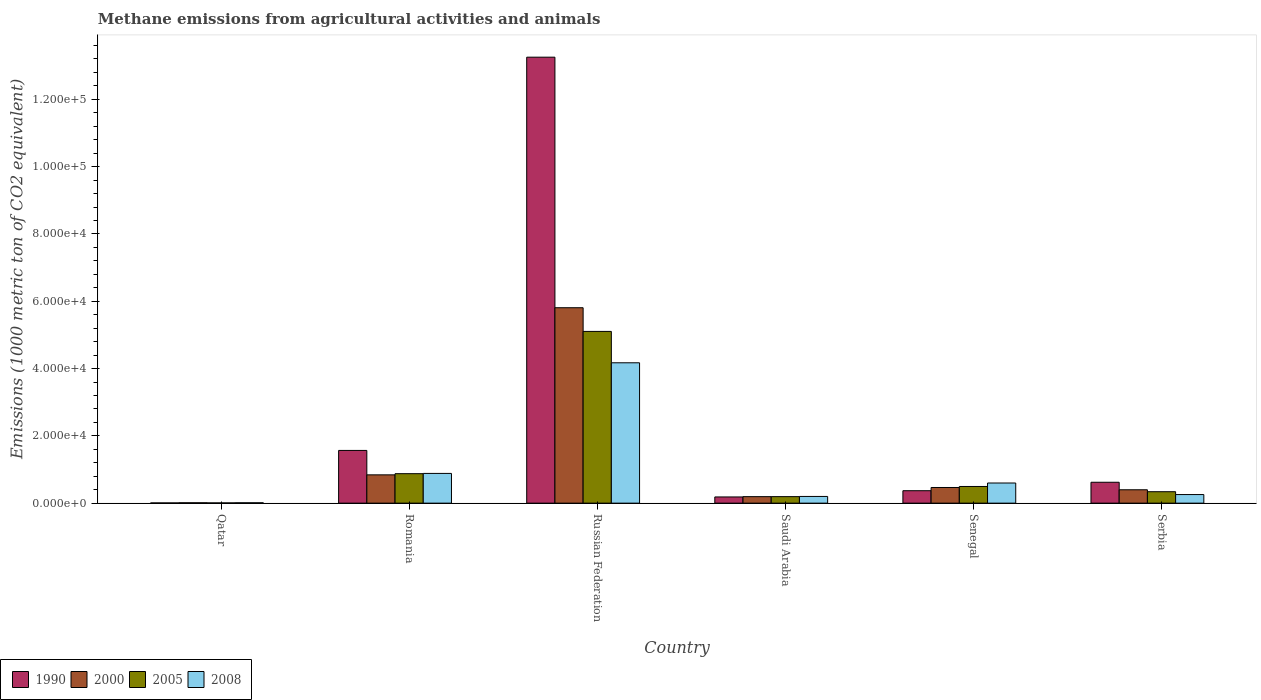How many different coloured bars are there?
Ensure brevity in your answer.  4. Are the number of bars on each tick of the X-axis equal?
Offer a terse response. Yes. How many bars are there on the 4th tick from the left?
Keep it short and to the point. 4. What is the label of the 6th group of bars from the left?
Ensure brevity in your answer.  Serbia. In how many cases, is the number of bars for a given country not equal to the number of legend labels?
Give a very brief answer. 0. What is the amount of methane emitted in 2000 in Qatar?
Your answer should be compact. 111.5. Across all countries, what is the maximum amount of methane emitted in 2000?
Provide a short and direct response. 5.81e+04. Across all countries, what is the minimum amount of methane emitted in 1990?
Your answer should be compact. 63.8. In which country was the amount of methane emitted in 1990 maximum?
Your answer should be very brief. Russian Federation. In which country was the amount of methane emitted in 2008 minimum?
Your response must be concise. Qatar. What is the total amount of methane emitted in 2000 in the graph?
Offer a very short reply. 7.72e+04. What is the difference between the amount of methane emitted in 2005 in Qatar and that in Saudi Arabia?
Offer a very short reply. -1866.2. What is the difference between the amount of methane emitted in 2005 in Senegal and the amount of methane emitted in 2000 in Serbia?
Provide a short and direct response. 979.8. What is the average amount of methane emitted in 1990 per country?
Keep it short and to the point. 2.67e+04. What is the difference between the amount of methane emitted of/in 2005 and amount of methane emitted of/in 2008 in Qatar?
Your answer should be very brief. -42.6. In how many countries, is the amount of methane emitted in 2008 greater than 64000 1000 metric ton?
Provide a succinct answer. 0. What is the ratio of the amount of methane emitted in 1990 in Qatar to that in Senegal?
Your answer should be very brief. 0.02. What is the difference between the highest and the second highest amount of methane emitted in 1990?
Your answer should be compact. 9455.9. What is the difference between the highest and the lowest amount of methane emitted in 2000?
Ensure brevity in your answer.  5.80e+04. In how many countries, is the amount of methane emitted in 2005 greater than the average amount of methane emitted in 2005 taken over all countries?
Make the answer very short. 1. What does the 1st bar from the left in Saudi Arabia represents?
Your response must be concise. 1990. Is it the case that in every country, the sum of the amount of methane emitted in 2000 and amount of methane emitted in 2005 is greater than the amount of methane emitted in 1990?
Your response must be concise. No. How many bars are there?
Provide a short and direct response. 24. Are all the bars in the graph horizontal?
Your answer should be very brief. No. How many countries are there in the graph?
Provide a short and direct response. 6. What is the difference between two consecutive major ticks on the Y-axis?
Provide a short and direct response. 2.00e+04. Are the values on the major ticks of Y-axis written in scientific E-notation?
Provide a succinct answer. Yes. Does the graph contain any zero values?
Ensure brevity in your answer.  No. Does the graph contain grids?
Make the answer very short. No. What is the title of the graph?
Your response must be concise. Methane emissions from agricultural activities and animals. Does "1968" appear as one of the legend labels in the graph?
Your answer should be compact. No. What is the label or title of the X-axis?
Your answer should be compact. Country. What is the label or title of the Y-axis?
Ensure brevity in your answer.  Emissions (1000 metric ton of CO2 equivalent). What is the Emissions (1000 metric ton of CO2 equivalent) of 1990 in Qatar?
Give a very brief answer. 63.8. What is the Emissions (1000 metric ton of CO2 equivalent) in 2000 in Qatar?
Offer a terse response. 111.5. What is the Emissions (1000 metric ton of CO2 equivalent) in 2005 in Qatar?
Your answer should be very brief. 67.4. What is the Emissions (1000 metric ton of CO2 equivalent) of 2008 in Qatar?
Your answer should be very brief. 110. What is the Emissions (1000 metric ton of CO2 equivalent) in 1990 in Romania?
Provide a succinct answer. 1.57e+04. What is the Emissions (1000 metric ton of CO2 equivalent) in 2000 in Romania?
Your answer should be very brief. 8409.3. What is the Emissions (1000 metric ton of CO2 equivalent) of 2005 in Romania?
Your response must be concise. 8756.8. What is the Emissions (1000 metric ton of CO2 equivalent) in 2008 in Romania?
Offer a very short reply. 8834.7. What is the Emissions (1000 metric ton of CO2 equivalent) of 1990 in Russian Federation?
Your response must be concise. 1.33e+05. What is the Emissions (1000 metric ton of CO2 equivalent) in 2000 in Russian Federation?
Ensure brevity in your answer.  5.81e+04. What is the Emissions (1000 metric ton of CO2 equivalent) of 2005 in Russian Federation?
Offer a terse response. 5.10e+04. What is the Emissions (1000 metric ton of CO2 equivalent) in 2008 in Russian Federation?
Offer a very short reply. 4.17e+04. What is the Emissions (1000 metric ton of CO2 equivalent) of 1990 in Saudi Arabia?
Your answer should be very brief. 1840.2. What is the Emissions (1000 metric ton of CO2 equivalent) of 2000 in Saudi Arabia?
Give a very brief answer. 1928.5. What is the Emissions (1000 metric ton of CO2 equivalent) of 2005 in Saudi Arabia?
Make the answer very short. 1933.6. What is the Emissions (1000 metric ton of CO2 equivalent) in 2008 in Saudi Arabia?
Make the answer very short. 1991.7. What is the Emissions (1000 metric ton of CO2 equivalent) of 1990 in Senegal?
Make the answer very short. 3695.6. What is the Emissions (1000 metric ton of CO2 equivalent) in 2000 in Senegal?
Your answer should be very brief. 4650.7. What is the Emissions (1000 metric ton of CO2 equivalent) of 2005 in Senegal?
Make the answer very short. 4955.1. What is the Emissions (1000 metric ton of CO2 equivalent) in 2008 in Senegal?
Your answer should be very brief. 5984.9. What is the Emissions (1000 metric ton of CO2 equivalent) in 1990 in Serbia?
Give a very brief answer. 6208.8. What is the Emissions (1000 metric ton of CO2 equivalent) of 2000 in Serbia?
Your answer should be very brief. 3975.3. What is the Emissions (1000 metric ton of CO2 equivalent) of 2005 in Serbia?
Your answer should be compact. 3399.6. What is the Emissions (1000 metric ton of CO2 equivalent) of 2008 in Serbia?
Offer a very short reply. 2550.7. Across all countries, what is the maximum Emissions (1000 metric ton of CO2 equivalent) of 1990?
Give a very brief answer. 1.33e+05. Across all countries, what is the maximum Emissions (1000 metric ton of CO2 equivalent) in 2000?
Keep it short and to the point. 5.81e+04. Across all countries, what is the maximum Emissions (1000 metric ton of CO2 equivalent) of 2005?
Provide a succinct answer. 5.10e+04. Across all countries, what is the maximum Emissions (1000 metric ton of CO2 equivalent) of 2008?
Provide a short and direct response. 4.17e+04. Across all countries, what is the minimum Emissions (1000 metric ton of CO2 equivalent) of 1990?
Your answer should be compact. 63.8. Across all countries, what is the minimum Emissions (1000 metric ton of CO2 equivalent) in 2000?
Offer a very short reply. 111.5. Across all countries, what is the minimum Emissions (1000 metric ton of CO2 equivalent) in 2005?
Provide a succinct answer. 67.4. Across all countries, what is the minimum Emissions (1000 metric ton of CO2 equivalent) in 2008?
Provide a short and direct response. 110. What is the total Emissions (1000 metric ton of CO2 equivalent) in 1990 in the graph?
Give a very brief answer. 1.60e+05. What is the total Emissions (1000 metric ton of CO2 equivalent) of 2000 in the graph?
Your answer should be very brief. 7.72e+04. What is the total Emissions (1000 metric ton of CO2 equivalent) of 2005 in the graph?
Ensure brevity in your answer.  7.01e+04. What is the total Emissions (1000 metric ton of CO2 equivalent) of 2008 in the graph?
Offer a very short reply. 6.12e+04. What is the difference between the Emissions (1000 metric ton of CO2 equivalent) of 1990 in Qatar and that in Romania?
Ensure brevity in your answer.  -1.56e+04. What is the difference between the Emissions (1000 metric ton of CO2 equivalent) in 2000 in Qatar and that in Romania?
Provide a succinct answer. -8297.8. What is the difference between the Emissions (1000 metric ton of CO2 equivalent) of 2005 in Qatar and that in Romania?
Offer a terse response. -8689.4. What is the difference between the Emissions (1000 metric ton of CO2 equivalent) of 2008 in Qatar and that in Romania?
Your answer should be very brief. -8724.7. What is the difference between the Emissions (1000 metric ton of CO2 equivalent) of 1990 in Qatar and that in Russian Federation?
Ensure brevity in your answer.  -1.32e+05. What is the difference between the Emissions (1000 metric ton of CO2 equivalent) of 2000 in Qatar and that in Russian Federation?
Provide a short and direct response. -5.80e+04. What is the difference between the Emissions (1000 metric ton of CO2 equivalent) in 2005 in Qatar and that in Russian Federation?
Make the answer very short. -5.10e+04. What is the difference between the Emissions (1000 metric ton of CO2 equivalent) in 2008 in Qatar and that in Russian Federation?
Ensure brevity in your answer.  -4.16e+04. What is the difference between the Emissions (1000 metric ton of CO2 equivalent) of 1990 in Qatar and that in Saudi Arabia?
Offer a terse response. -1776.4. What is the difference between the Emissions (1000 metric ton of CO2 equivalent) of 2000 in Qatar and that in Saudi Arabia?
Your answer should be very brief. -1817. What is the difference between the Emissions (1000 metric ton of CO2 equivalent) in 2005 in Qatar and that in Saudi Arabia?
Provide a succinct answer. -1866.2. What is the difference between the Emissions (1000 metric ton of CO2 equivalent) of 2008 in Qatar and that in Saudi Arabia?
Make the answer very short. -1881.7. What is the difference between the Emissions (1000 metric ton of CO2 equivalent) of 1990 in Qatar and that in Senegal?
Offer a terse response. -3631.8. What is the difference between the Emissions (1000 metric ton of CO2 equivalent) in 2000 in Qatar and that in Senegal?
Provide a succinct answer. -4539.2. What is the difference between the Emissions (1000 metric ton of CO2 equivalent) of 2005 in Qatar and that in Senegal?
Your answer should be very brief. -4887.7. What is the difference between the Emissions (1000 metric ton of CO2 equivalent) of 2008 in Qatar and that in Senegal?
Your response must be concise. -5874.9. What is the difference between the Emissions (1000 metric ton of CO2 equivalent) of 1990 in Qatar and that in Serbia?
Your answer should be very brief. -6145. What is the difference between the Emissions (1000 metric ton of CO2 equivalent) of 2000 in Qatar and that in Serbia?
Provide a succinct answer. -3863.8. What is the difference between the Emissions (1000 metric ton of CO2 equivalent) in 2005 in Qatar and that in Serbia?
Offer a terse response. -3332.2. What is the difference between the Emissions (1000 metric ton of CO2 equivalent) of 2008 in Qatar and that in Serbia?
Your response must be concise. -2440.7. What is the difference between the Emissions (1000 metric ton of CO2 equivalent) of 1990 in Romania and that in Russian Federation?
Offer a very short reply. -1.17e+05. What is the difference between the Emissions (1000 metric ton of CO2 equivalent) in 2000 in Romania and that in Russian Federation?
Keep it short and to the point. -4.97e+04. What is the difference between the Emissions (1000 metric ton of CO2 equivalent) in 2005 in Romania and that in Russian Federation?
Keep it short and to the point. -4.23e+04. What is the difference between the Emissions (1000 metric ton of CO2 equivalent) of 2008 in Romania and that in Russian Federation?
Offer a terse response. -3.29e+04. What is the difference between the Emissions (1000 metric ton of CO2 equivalent) of 1990 in Romania and that in Saudi Arabia?
Your response must be concise. 1.38e+04. What is the difference between the Emissions (1000 metric ton of CO2 equivalent) of 2000 in Romania and that in Saudi Arabia?
Provide a short and direct response. 6480.8. What is the difference between the Emissions (1000 metric ton of CO2 equivalent) of 2005 in Romania and that in Saudi Arabia?
Offer a very short reply. 6823.2. What is the difference between the Emissions (1000 metric ton of CO2 equivalent) of 2008 in Romania and that in Saudi Arabia?
Your response must be concise. 6843. What is the difference between the Emissions (1000 metric ton of CO2 equivalent) of 1990 in Romania and that in Senegal?
Your answer should be compact. 1.20e+04. What is the difference between the Emissions (1000 metric ton of CO2 equivalent) of 2000 in Romania and that in Senegal?
Offer a terse response. 3758.6. What is the difference between the Emissions (1000 metric ton of CO2 equivalent) in 2005 in Romania and that in Senegal?
Your answer should be very brief. 3801.7. What is the difference between the Emissions (1000 metric ton of CO2 equivalent) in 2008 in Romania and that in Senegal?
Ensure brevity in your answer.  2849.8. What is the difference between the Emissions (1000 metric ton of CO2 equivalent) in 1990 in Romania and that in Serbia?
Provide a short and direct response. 9455.9. What is the difference between the Emissions (1000 metric ton of CO2 equivalent) of 2000 in Romania and that in Serbia?
Provide a succinct answer. 4434. What is the difference between the Emissions (1000 metric ton of CO2 equivalent) of 2005 in Romania and that in Serbia?
Your answer should be very brief. 5357.2. What is the difference between the Emissions (1000 metric ton of CO2 equivalent) in 2008 in Romania and that in Serbia?
Provide a succinct answer. 6284. What is the difference between the Emissions (1000 metric ton of CO2 equivalent) of 1990 in Russian Federation and that in Saudi Arabia?
Your answer should be very brief. 1.31e+05. What is the difference between the Emissions (1000 metric ton of CO2 equivalent) in 2000 in Russian Federation and that in Saudi Arabia?
Your answer should be compact. 5.61e+04. What is the difference between the Emissions (1000 metric ton of CO2 equivalent) of 2005 in Russian Federation and that in Saudi Arabia?
Your response must be concise. 4.91e+04. What is the difference between the Emissions (1000 metric ton of CO2 equivalent) in 2008 in Russian Federation and that in Saudi Arabia?
Ensure brevity in your answer.  3.97e+04. What is the difference between the Emissions (1000 metric ton of CO2 equivalent) in 1990 in Russian Federation and that in Senegal?
Offer a terse response. 1.29e+05. What is the difference between the Emissions (1000 metric ton of CO2 equivalent) of 2000 in Russian Federation and that in Senegal?
Provide a short and direct response. 5.34e+04. What is the difference between the Emissions (1000 metric ton of CO2 equivalent) of 2005 in Russian Federation and that in Senegal?
Make the answer very short. 4.61e+04. What is the difference between the Emissions (1000 metric ton of CO2 equivalent) in 2008 in Russian Federation and that in Senegal?
Your answer should be very brief. 3.57e+04. What is the difference between the Emissions (1000 metric ton of CO2 equivalent) of 1990 in Russian Federation and that in Serbia?
Keep it short and to the point. 1.26e+05. What is the difference between the Emissions (1000 metric ton of CO2 equivalent) in 2000 in Russian Federation and that in Serbia?
Your answer should be very brief. 5.41e+04. What is the difference between the Emissions (1000 metric ton of CO2 equivalent) in 2005 in Russian Federation and that in Serbia?
Make the answer very short. 4.76e+04. What is the difference between the Emissions (1000 metric ton of CO2 equivalent) in 2008 in Russian Federation and that in Serbia?
Make the answer very short. 3.92e+04. What is the difference between the Emissions (1000 metric ton of CO2 equivalent) of 1990 in Saudi Arabia and that in Senegal?
Your response must be concise. -1855.4. What is the difference between the Emissions (1000 metric ton of CO2 equivalent) in 2000 in Saudi Arabia and that in Senegal?
Your answer should be compact. -2722.2. What is the difference between the Emissions (1000 metric ton of CO2 equivalent) in 2005 in Saudi Arabia and that in Senegal?
Give a very brief answer. -3021.5. What is the difference between the Emissions (1000 metric ton of CO2 equivalent) of 2008 in Saudi Arabia and that in Senegal?
Your response must be concise. -3993.2. What is the difference between the Emissions (1000 metric ton of CO2 equivalent) of 1990 in Saudi Arabia and that in Serbia?
Make the answer very short. -4368.6. What is the difference between the Emissions (1000 metric ton of CO2 equivalent) of 2000 in Saudi Arabia and that in Serbia?
Provide a short and direct response. -2046.8. What is the difference between the Emissions (1000 metric ton of CO2 equivalent) in 2005 in Saudi Arabia and that in Serbia?
Provide a succinct answer. -1466. What is the difference between the Emissions (1000 metric ton of CO2 equivalent) of 2008 in Saudi Arabia and that in Serbia?
Your answer should be very brief. -559. What is the difference between the Emissions (1000 metric ton of CO2 equivalent) in 1990 in Senegal and that in Serbia?
Provide a short and direct response. -2513.2. What is the difference between the Emissions (1000 metric ton of CO2 equivalent) of 2000 in Senegal and that in Serbia?
Keep it short and to the point. 675.4. What is the difference between the Emissions (1000 metric ton of CO2 equivalent) in 2005 in Senegal and that in Serbia?
Keep it short and to the point. 1555.5. What is the difference between the Emissions (1000 metric ton of CO2 equivalent) in 2008 in Senegal and that in Serbia?
Make the answer very short. 3434.2. What is the difference between the Emissions (1000 metric ton of CO2 equivalent) of 1990 in Qatar and the Emissions (1000 metric ton of CO2 equivalent) of 2000 in Romania?
Ensure brevity in your answer.  -8345.5. What is the difference between the Emissions (1000 metric ton of CO2 equivalent) in 1990 in Qatar and the Emissions (1000 metric ton of CO2 equivalent) in 2005 in Romania?
Your response must be concise. -8693. What is the difference between the Emissions (1000 metric ton of CO2 equivalent) of 1990 in Qatar and the Emissions (1000 metric ton of CO2 equivalent) of 2008 in Romania?
Make the answer very short. -8770.9. What is the difference between the Emissions (1000 metric ton of CO2 equivalent) in 2000 in Qatar and the Emissions (1000 metric ton of CO2 equivalent) in 2005 in Romania?
Offer a very short reply. -8645.3. What is the difference between the Emissions (1000 metric ton of CO2 equivalent) of 2000 in Qatar and the Emissions (1000 metric ton of CO2 equivalent) of 2008 in Romania?
Your answer should be compact. -8723.2. What is the difference between the Emissions (1000 metric ton of CO2 equivalent) of 2005 in Qatar and the Emissions (1000 metric ton of CO2 equivalent) of 2008 in Romania?
Ensure brevity in your answer.  -8767.3. What is the difference between the Emissions (1000 metric ton of CO2 equivalent) in 1990 in Qatar and the Emissions (1000 metric ton of CO2 equivalent) in 2000 in Russian Federation?
Provide a short and direct response. -5.80e+04. What is the difference between the Emissions (1000 metric ton of CO2 equivalent) in 1990 in Qatar and the Emissions (1000 metric ton of CO2 equivalent) in 2005 in Russian Federation?
Give a very brief answer. -5.10e+04. What is the difference between the Emissions (1000 metric ton of CO2 equivalent) of 1990 in Qatar and the Emissions (1000 metric ton of CO2 equivalent) of 2008 in Russian Federation?
Ensure brevity in your answer.  -4.16e+04. What is the difference between the Emissions (1000 metric ton of CO2 equivalent) of 2000 in Qatar and the Emissions (1000 metric ton of CO2 equivalent) of 2005 in Russian Federation?
Give a very brief answer. -5.09e+04. What is the difference between the Emissions (1000 metric ton of CO2 equivalent) of 2000 in Qatar and the Emissions (1000 metric ton of CO2 equivalent) of 2008 in Russian Federation?
Offer a terse response. -4.16e+04. What is the difference between the Emissions (1000 metric ton of CO2 equivalent) in 2005 in Qatar and the Emissions (1000 metric ton of CO2 equivalent) in 2008 in Russian Federation?
Give a very brief answer. -4.16e+04. What is the difference between the Emissions (1000 metric ton of CO2 equivalent) in 1990 in Qatar and the Emissions (1000 metric ton of CO2 equivalent) in 2000 in Saudi Arabia?
Your answer should be very brief. -1864.7. What is the difference between the Emissions (1000 metric ton of CO2 equivalent) of 1990 in Qatar and the Emissions (1000 metric ton of CO2 equivalent) of 2005 in Saudi Arabia?
Ensure brevity in your answer.  -1869.8. What is the difference between the Emissions (1000 metric ton of CO2 equivalent) of 1990 in Qatar and the Emissions (1000 metric ton of CO2 equivalent) of 2008 in Saudi Arabia?
Ensure brevity in your answer.  -1927.9. What is the difference between the Emissions (1000 metric ton of CO2 equivalent) of 2000 in Qatar and the Emissions (1000 metric ton of CO2 equivalent) of 2005 in Saudi Arabia?
Make the answer very short. -1822.1. What is the difference between the Emissions (1000 metric ton of CO2 equivalent) of 2000 in Qatar and the Emissions (1000 metric ton of CO2 equivalent) of 2008 in Saudi Arabia?
Provide a short and direct response. -1880.2. What is the difference between the Emissions (1000 metric ton of CO2 equivalent) of 2005 in Qatar and the Emissions (1000 metric ton of CO2 equivalent) of 2008 in Saudi Arabia?
Your response must be concise. -1924.3. What is the difference between the Emissions (1000 metric ton of CO2 equivalent) of 1990 in Qatar and the Emissions (1000 metric ton of CO2 equivalent) of 2000 in Senegal?
Ensure brevity in your answer.  -4586.9. What is the difference between the Emissions (1000 metric ton of CO2 equivalent) of 1990 in Qatar and the Emissions (1000 metric ton of CO2 equivalent) of 2005 in Senegal?
Ensure brevity in your answer.  -4891.3. What is the difference between the Emissions (1000 metric ton of CO2 equivalent) of 1990 in Qatar and the Emissions (1000 metric ton of CO2 equivalent) of 2008 in Senegal?
Ensure brevity in your answer.  -5921.1. What is the difference between the Emissions (1000 metric ton of CO2 equivalent) in 2000 in Qatar and the Emissions (1000 metric ton of CO2 equivalent) in 2005 in Senegal?
Offer a terse response. -4843.6. What is the difference between the Emissions (1000 metric ton of CO2 equivalent) in 2000 in Qatar and the Emissions (1000 metric ton of CO2 equivalent) in 2008 in Senegal?
Offer a very short reply. -5873.4. What is the difference between the Emissions (1000 metric ton of CO2 equivalent) in 2005 in Qatar and the Emissions (1000 metric ton of CO2 equivalent) in 2008 in Senegal?
Offer a very short reply. -5917.5. What is the difference between the Emissions (1000 metric ton of CO2 equivalent) of 1990 in Qatar and the Emissions (1000 metric ton of CO2 equivalent) of 2000 in Serbia?
Give a very brief answer. -3911.5. What is the difference between the Emissions (1000 metric ton of CO2 equivalent) in 1990 in Qatar and the Emissions (1000 metric ton of CO2 equivalent) in 2005 in Serbia?
Ensure brevity in your answer.  -3335.8. What is the difference between the Emissions (1000 metric ton of CO2 equivalent) of 1990 in Qatar and the Emissions (1000 metric ton of CO2 equivalent) of 2008 in Serbia?
Give a very brief answer. -2486.9. What is the difference between the Emissions (1000 metric ton of CO2 equivalent) in 2000 in Qatar and the Emissions (1000 metric ton of CO2 equivalent) in 2005 in Serbia?
Give a very brief answer. -3288.1. What is the difference between the Emissions (1000 metric ton of CO2 equivalent) in 2000 in Qatar and the Emissions (1000 metric ton of CO2 equivalent) in 2008 in Serbia?
Provide a short and direct response. -2439.2. What is the difference between the Emissions (1000 metric ton of CO2 equivalent) in 2005 in Qatar and the Emissions (1000 metric ton of CO2 equivalent) in 2008 in Serbia?
Offer a terse response. -2483.3. What is the difference between the Emissions (1000 metric ton of CO2 equivalent) of 1990 in Romania and the Emissions (1000 metric ton of CO2 equivalent) of 2000 in Russian Federation?
Keep it short and to the point. -4.24e+04. What is the difference between the Emissions (1000 metric ton of CO2 equivalent) in 1990 in Romania and the Emissions (1000 metric ton of CO2 equivalent) in 2005 in Russian Federation?
Your answer should be very brief. -3.54e+04. What is the difference between the Emissions (1000 metric ton of CO2 equivalent) in 1990 in Romania and the Emissions (1000 metric ton of CO2 equivalent) in 2008 in Russian Federation?
Keep it short and to the point. -2.60e+04. What is the difference between the Emissions (1000 metric ton of CO2 equivalent) of 2000 in Romania and the Emissions (1000 metric ton of CO2 equivalent) of 2005 in Russian Federation?
Your answer should be very brief. -4.26e+04. What is the difference between the Emissions (1000 metric ton of CO2 equivalent) in 2000 in Romania and the Emissions (1000 metric ton of CO2 equivalent) in 2008 in Russian Federation?
Give a very brief answer. -3.33e+04. What is the difference between the Emissions (1000 metric ton of CO2 equivalent) in 2005 in Romania and the Emissions (1000 metric ton of CO2 equivalent) in 2008 in Russian Federation?
Offer a terse response. -3.30e+04. What is the difference between the Emissions (1000 metric ton of CO2 equivalent) in 1990 in Romania and the Emissions (1000 metric ton of CO2 equivalent) in 2000 in Saudi Arabia?
Provide a short and direct response. 1.37e+04. What is the difference between the Emissions (1000 metric ton of CO2 equivalent) of 1990 in Romania and the Emissions (1000 metric ton of CO2 equivalent) of 2005 in Saudi Arabia?
Provide a succinct answer. 1.37e+04. What is the difference between the Emissions (1000 metric ton of CO2 equivalent) of 1990 in Romania and the Emissions (1000 metric ton of CO2 equivalent) of 2008 in Saudi Arabia?
Your response must be concise. 1.37e+04. What is the difference between the Emissions (1000 metric ton of CO2 equivalent) of 2000 in Romania and the Emissions (1000 metric ton of CO2 equivalent) of 2005 in Saudi Arabia?
Your answer should be compact. 6475.7. What is the difference between the Emissions (1000 metric ton of CO2 equivalent) in 2000 in Romania and the Emissions (1000 metric ton of CO2 equivalent) in 2008 in Saudi Arabia?
Your answer should be very brief. 6417.6. What is the difference between the Emissions (1000 metric ton of CO2 equivalent) of 2005 in Romania and the Emissions (1000 metric ton of CO2 equivalent) of 2008 in Saudi Arabia?
Keep it short and to the point. 6765.1. What is the difference between the Emissions (1000 metric ton of CO2 equivalent) in 1990 in Romania and the Emissions (1000 metric ton of CO2 equivalent) in 2000 in Senegal?
Provide a short and direct response. 1.10e+04. What is the difference between the Emissions (1000 metric ton of CO2 equivalent) in 1990 in Romania and the Emissions (1000 metric ton of CO2 equivalent) in 2005 in Senegal?
Give a very brief answer. 1.07e+04. What is the difference between the Emissions (1000 metric ton of CO2 equivalent) of 1990 in Romania and the Emissions (1000 metric ton of CO2 equivalent) of 2008 in Senegal?
Provide a short and direct response. 9679.8. What is the difference between the Emissions (1000 metric ton of CO2 equivalent) in 2000 in Romania and the Emissions (1000 metric ton of CO2 equivalent) in 2005 in Senegal?
Your response must be concise. 3454.2. What is the difference between the Emissions (1000 metric ton of CO2 equivalent) of 2000 in Romania and the Emissions (1000 metric ton of CO2 equivalent) of 2008 in Senegal?
Give a very brief answer. 2424.4. What is the difference between the Emissions (1000 metric ton of CO2 equivalent) of 2005 in Romania and the Emissions (1000 metric ton of CO2 equivalent) of 2008 in Senegal?
Make the answer very short. 2771.9. What is the difference between the Emissions (1000 metric ton of CO2 equivalent) in 1990 in Romania and the Emissions (1000 metric ton of CO2 equivalent) in 2000 in Serbia?
Your response must be concise. 1.17e+04. What is the difference between the Emissions (1000 metric ton of CO2 equivalent) of 1990 in Romania and the Emissions (1000 metric ton of CO2 equivalent) of 2005 in Serbia?
Provide a succinct answer. 1.23e+04. What is the difference between the Emissions (1000 metric ton of CO2 equivalent) of 1990 in Romania and the Emissions (1000 metric ton of CO2 equivalent) of 2008 in Serbia?
Your answer should be compact. 1.31e+04. What is the difference between the Emissions (1000 metric ton of CO2 equivalent) of 2000 in Romania and the Emissions (1000 metric ton of CO2 equivalent) of 2005 in Serbia?
Offer a very short reply. 5009.7. What is the difference between the Emissions (1000 metric ton of CO2 equivalent) in 2000 in Romania and the Emissions (1000 metric ton of CO2 equivalent) in 2008 in Serbia?
Your answer should be very brief. 5858.6. What is the difference between the Emissions (1000 metric ton of CO2 equivalent) in 2005 in Romania and the Emissions (1000 metric ton of CO2 equivalent) in 2008 in Serbia?
Keep it short and to the point. 6206.1. What is the difference between the Emissions (1000 metric ton of CO2 equivalent) in 1990 in Russian Federation and the Emissions (1000 metric ton of CO2 equivalent) in 2000 in Saudi Arabia?
Provide a succinct answer. 1.31e+05. What is the difference between the Emissions (1000 metric ton of CO2 equivalent) of 1990 in Russian Federation and the Emissions (1000 metric ton of CO2 equivalent) of 2005 in Saudi Arabia?
Offer a terse response. 1.31e+05. What is the difference between the Emissions (1000 metric ton of CO2 equivalent) in 1990 in Russian Federation and the Emissions (1000 metric ton of CO2 equivalent) in 2008 in Saudi Arabia?
Offer a very short reply. 1.31e+05. What is the difference between the Emissions (1000 metric ton of CO2 equivalent) in 2000 in Russian Federation and the Emissions (1000 metric ton of CO2 equivalent) in 2005 in Saudi Arabia?
Give a very brief answer. 5.61e+04. What is the difference between the Emissions (1000 metric ton of CO2 equivalent) in 2000 in Russian Federation and the Emissions (1000 metric ton of CO2 equivalent) in 2008 in Saudi Arabia?
Keep it short and to the point. 5.61e+04. What is the difference between the Emissions (1000 metric ton of CO2 equivalent) of 2005 in Russian Federation and the Emissions (1000 metric ton of CO2 equivalent) of 2008 in Saudi Arabia?
Make the answer very short. 4.90e+04. What is the difference between the Emissions (1000 metric ton of CO2 equivalent) in 1990 in Russian Federation and the Emissions (1000 metric ton of CO2 equivalent) in 2000 in Senegal?
Your response must be concise. 1.28e+05. What is the difference between the Emissions (1000 metric ton of CO2 equivalent) in 1990 in Russian Federation and the Emissions (1000 metric ton of CO2 equivalent) in 2005 in Senegal?
Ensure brevity in your answer.  1.28e+05. What is the difference between the Emissions (1000 metric ton of CO2 equivalent) of 1990 in Russian Federation and the Emissions (1000 metric ton of CO2 equivalent) of 2008 in Senegal?
Give a very brief answer. 1.27e+05. What is the difference between the Emissions (1000 metric ton of CO2 equivalent) in 2000 in Russian Federation and the Emissions (1000 metric ton of CO2 equivalent) in 2005 in Senegal?
Give a very brief answer. 5.31e+04. What is the difference between the Emissions (1000 metric ton of CO2 equivalent) in 2000 in Russian Federation and the Emissions (1000 metric ton of CO2 equivalent) in 2008 in Senegal?
Your answer should be compact. 5.21e+04. What is the difference between the Emissions (1000 metric ton of CO2 equivalent) of 2005 in Russian Federation and the Emissions (1000 metric ton of CO2 equivalent) of 2008 in Senegal?
Make the answer very short. 4.51e+04. What is the difference between the Emissions (1000 metric ton of CO2 equivalent) in 1990 in Russian Federation and the Emissions (1000 metric ton of CO2 equivalent) in 2000 in Serbia?
Offer a terse response. 1.29e+05. What is the difference between the Emissions (1000 metric ton of CO2 equivalent) of 1990 in Russian Federation and the Emissions (1000 metric ton of CO2 equivalent) of 2005 in Serbia?
Offer a terse response. 1.29e+05. What is the difference between the Emissions (1000 metric ton of CO2 equivalent) in 1990 in Russian Federation and the Emissions (1000 metric ton of CO2 equivalent) in 2008 in Serbia?
Provide a succinct answer. 1.30e+05. What is the difference between the Emissions (1000 metric ton of CO2 equivalent) in 2000 in Russian Federation and the Emissions (1000 metric ton of CO2 equivalent) in 2005 in Serbia?
Ensure brevity in your answer.  5.47e+04. What is the difference between the Emissions (1000 metric ton of CO2 equivalent) of 2000 in Russian Federation and the Emissions (1000 metric ton of CO2 equivalent) of 2008 in Serbia?
Provide a succinct answer. 5.55e+04. What is the difference between the Emissions (1000 metric ton of CO2 equivalent) of 2005 in Russian Federation and the Emissions (1000 metric ton of CO2 equivalent) of 2008 in Serbia?
Give a very brief answer. 4.85e+04. What is the difference between the Emissions (1000 metric ton of CO2 equivalent) of 1990 in Saudi Arabia and the Emissions (1000 metric ton of CO2 equivalent) of 2000 in Senegal?
Your response must be concise. -2810.5. What is the difference between the Emissions (1000 metric ton of CO2 equivalent) in 1990 in Saudi Arabia and the Emissions (1000 metric ton of CO2 equivalent) in 2005 in Senegal?
Make the answer very short. -3114.9. What is the difference between the Emissions (1000 metric ton of CO2 equivalent) in 1990 in Saudi Arabia and the Emissions (1000 metric ton of CO2 equivalent) in 2008 in Senegal?
Ensure brevity in your answer.  -4144.7. What is the difference between the Emissions (1000 metric ton of CO2 equivalent) of 2000 in Saudi Arabia and the Emissions (1000 metric ton of CO2 equivalent) of 2005 in Senegal?
Your answer should be very brief. -3026.6. What is the difference between the Emissions (1000 metric ton of CO2 equivalent) of 2000 in Saudi Arabia and the Emissions (1000 metric ton of CO2 equivalent) of 2008 in Senegal?
Your answer should be very brief. -4056.4. What is the difference between the Emissions (1000 metric ton of CO2 equivalent) of 2005 in Saudi Arabia and the Emissions (1000 metric ton of CO2 equivalent) of 2008 in Senegal?
Your response must be concise. -4051.3. What is the difference between the Emissions (1000 metric ton of CO2 equivalent) of 1990 in Saudi Arabia and the Emissions (1000 metric ton of CO2 equivalent) of 2000 in Serbia?
Your answer should be compact. -2135.1. What is the difference between the Emissions (1000 metric ton of CO2 equivalent) of 1990 in Saudi Arabia and the Emissions (1000 metric ton of CO2 equivalent) of 2005 in Serbia?
Your answer should be compact. -1559.4. What is the difference between the Emissions (1000 metric ton of CO2 equivalent) in 1990 in Saudi Arabia and the Emissions (1000 metric ton of CO2 equivalent) in 2008 in Serbia?
Ensure brevity in your answer.  -710.5. What is the difference between the Emissions (1000 metric ton of CO2 equivalent) in 2000 in Saudi Arabia and the Emissions (1000 metric ton of CO2 equivalent) in 2005 in Serbia?
Provide a succinct answer. -1471.1. What is the difference between the Emissions (1000 metric ton of CO2 equivalent) of 2000 in Saudi Arabia and the Emissions (1000 metric ton of CO2 equivalent) of 2008 in Serbia?
Your answer should be very brief. -622.2. What is the difference between the Emissions (1000 metric ton of CO2 equivalent) in 2005 in Saudi Arabia and the Emissions (1000 metric ton of CO2 equivalent) in 2008 in Serbia?
Ensure brevity in your answer.  -617.1. What is the difference between the Emissions (1000 metric ton of CO2 equivalent) in 1990 in Senegal and the Emissions (1000 metric ton of CO2 equivalent) in 2000 in Serbia?
Ensure brevity in your answer.  -279.7. What is the difference between the Emissions (1000 metric ton of CO2 equivalent) of 1990 in Senegal and the Emissions (1000 metric ton of CO2 equivalent) of 2005 in Serbia?
Ensure brevity in your answer.  296. What is the difference between the Emissions (1000 metric ton of CO2 equivalent) in 1990 in Senegal and the Emissions (1000 metric ton of CO2 equivalent) in 2008 in Serbia?
Keep it short and to the point. 1144.9. What is the difference between the Emissions (1000 metric ton of CO2 equivalent) of 2000 in Senegal and the Emissions (1000 metric ton of CO2 equivalent) of 2005 in Serbia?
Your answer should be very brief. 1251.1. What is the difference between the Emissions (1000 metric ton of CO2 equivalent) in 2000 in Senegal and the Emissions (1000 metric ton of CO2 equivalent) in 2008 in Serbia?
Ensure brevity in your answer.  2100. What is the difference between the Emissions (1000 metric ton of CO2 equivalent) in 2005 in Senegal and the Emissions (1000 metric ton of CO2 equivalent) in 2008 in Serbia?
Provide a short and direct response. 2404.4. What is the average Emissions (1000 metric ton of CO2 equivalent) of 1990 per country?
Your response must be concise. 2.67e+04. What is the average Emissions (1000 metric ton of CO2 equivalent) in 2000 per country?
Make the answer very short. 1.29e+04. What is the average Emissions (1000 metric ton of CO2 equivalent) of 2005 per country?
Provide a succinct answer. 1.17e+04. What is the average Emissions (1000 metric ton of CO2 equivalent) in 2008 per country?
Your answer should be very brief. 1.02e+04. What is the difference between the Emissions (1000 metric ton of CO2 equivalent) in 1990 and Emissions (1000 metric ton of CO2 equivalent) in 2000 in Qatar?
Make the answer very short. -47.7. What is the difference between the Emissions (1000 metric ton of CO2 equivalent) of 1990 and Emissions (1000 metric ton of CO2 equivalent) of 2005 in Qatar?
Give a very brief answer. -3.6. What is the difference between the Emissions (1000 metric ton of CO2 equivalent) of 1990 and Emissions (1000 metric ton of CO2 equivalent) of 2008 in Qatar?
Offer a very short reply. -46.2. What is the difference between the Emissions (1000 metric ton of CO2 equivalent) of 2000 and Emissions (1000 metric ton of CO2 equivalent) of 2005 in Qatar?
Make the answer very short. 44.1. What is the difference between the Emissions (1000 metric ton of CO2 equivalent) of 2000 and Emissions (1000 metric ton of CO2 equivalent) of 2008 in Qatar?
Your response must be concise. 1.5. What is the difference between the Emissions (1000 metric ton of CO2 equivalent) in 2005 and Emissions (1000 metric ton of CO2 equivalent) in 2008 in Qatar?
Give a very brief answer. -42.6. What is the difference between the Emissions (1000 metric ton of CO2 equivalent) in 1990 and Emissions (1000 metric ton of CO2 equivalent) in 2000 in Romania?
Provide a succinct answer. 7255.4. What is the difference between the Emissions (1000 metric ton of CO2 equivalent) in 1990 and Emissions (1000 metric ton of CO2 equivalent) in 2005 in Romania?
Your answer should be compact. 6907.9. What is the difference between the Emissions (1000 metric ton of CO2 equivalent) in 1990 and Emissions (1000 metric ton of CO2 equivalent) in 2008 in Romania?
Your answer should be very brief. 6830. What is the difference between the Emissions (1000 metric ton of CO2 equivalent) of 2000 and Emissions (1000 metric ton of CO2 equivalent) of 2005 in Romania?
Keep it short and to the point. -347.5. What is the difference between the Emissions (1000 metric ton of CO2 equivalent) in 2000 and Emissions (1000 metric ton of CO2 equivalent) in 2008 in Romania?
Ensure brevity in your answer.  -425.4. What is the difference between the Emissions (1000 metric ton of CO2 equivalent) in 2005 and Emissions (1000 metric ton of CO2 equivalent) in 2008 in Romania?
Your answer should be very brief. -77.9. What is the difference between the Emissions (1000 metric ton of CO2 equivalent) in 1990 and Emissions (1000 metric ton of CO2 equivalent) in 2000 in Russian Federation?
Give a very brief answer. 7.45e+04. What is the difference between the Emissions (1000 metric ton of CO2 equivalent) of 1990 and Emissions (1000 metric ton of CO2 equivalent) of 2005 in Russian Federation?
Ensure brevity in your answer.  8.15e+04. What is the difference between the Emissions (1000 metric ton of CO2 equivalent) of 1990 and Emissions (1000 metric ton of CO2 equivalent) of 2008 in Russian Federation?
Keep it short and to the point. 9.08e+04. What is the difference between the Emissions (1000 metric ton of CO2 equivalent) in 2000 and Emissions (1000 metric ton of CO2 equivalent) in 2005 in Russian Federation?
Make the answer very short. 7040. What is the difference between the Emissions (1000 metric ton of CO2 equivalent) in 2000 and Emissions (1000 metric ton of CO2 equivalent) in 2008 in Russian Federation?
Offer a terse response. 1.64e+04. What is the difference between the Emissions (1000 metric ton of CO2 equivalent) of 2005 and Emissions (1000 metric ton of CO2 equivalent) of 2008 in Russian Federation?
Make the answer very short. 9324.6. What is the difference between the Emissions (1000 metric ton of CO2 equivalent) in 1990 and Emissions (1000 metric ton of CO2 equivalent) in 2000 in Saudi Arabia?
Provide a short and direct response. -88.3. What is the difference between the Emissions (1000 metric ton of CO2 equivalent) of 1990 and Emissions (1000 metric ton of CO2 equivalent) of 2005 in Saudi Arabia?
Provide a succinct answer. -93.4. What is the difference between the Emissions (1000 metric ton of CO2 equivalent) of 1990 and Emissions (1000 metric ton of CO2 equivalent) of 2008 in Saudi Arabia?
Provide a succinct answer. -151.5. What is the difference between the Emissions (1000 metric ton of CO2 equivalent) in 2000 and Emissions (1000 metric ton of CO2 equivalent) in 2005 in Saudi Arabia?
Your answer should be compact. -5.1. What is the difference between the Emissions (1000 metric ton of CO2 equivalent) of 2000 and Emissions (1000 metric ton of CO2 equivalent) of 2008 in Saudi Arabia?
Ensure brevity in your answer.  -63.2. What is the difference between the Emissions (1000 metric ton of CO2 equivalent) of 2005 and Emissions (1000 metric ton of CO2 equivalent) of 2008 in Saudi Arabia?
Give a very brief answer. -58.1. What is the difference between the Emissions (1000 metric ton of CO2 equivalent) of 1990 and Emissions (1000 metric ton of CO2 equivalent) of 2000 in Senegal?
Ensure brevity in your answer.  -955.1. What is the difference between the Emissions (1000 metric ton of CO2 equivalent) of 1990 and Emissions (1000 metric ton of CO2 equivalent) of 2005 in Senegal?
Offer a very short reply. -1259.5. What is the difference between the Emissions (1000 metric ton of CO2 equivalent) in 1990 and Emissions (1000 metric ton of CO2 equivalent) in 2008 in Senegal?
Make the answer very short. -2289.3. What is the difference between the Emissions (1000 metric ton of CO2 equivalent) in 2000 and Emissions (1000 metric ton of CO2 equivalent) in 2005 in Senegal?
Your answer should be very brief. -304.4. What is the difference between the Emissions (1000 metric ton of CO2 equivalent) of 2000 and Emissions (1000 metric ton of CO2 equivalent) of 2008 in Senegal?
Make the answer very short. -1334.2. What is the difference between the Emissions (1000 metric ton of CO2 equivalent) of 2005 and Emissions (1000 metric ton of CO2 equivalent) of 2008 in Senegal?
Offer a very short reply. -1029.8. What is the difference between the Emissions (1000 metric ton of CO2 equivalent) in 1990 and Emissions (1000 metric ton of CO2 equivalent) in 2000 in Serbia?
Your answer should be very brief. 2233.5. What is the difference between the Emissions (1000 metric ton of CO2 equivalent) of 1990 and Emissions (1000 metric ton of CO2 equivalent) of 2005 in Serbia?
Provide a succinct answer. 2809.2. What is the difference between the Emissions (1000 metric ton of CO2 equivalent) of 1990 and Emissions (1000 metric ton of CO2 equivalent) of 2008 in Serbia?
Offer a very short reply. 3658.1. What is the difference between the Emissions (1000 metric ton of CO2 equivalent) of 2000 and Emissions (1000 metric ton of CO2 equivalent) of 2005 in Serbia?
Ensure brevity in your answer.  575.7. What is the difference between the Emissions (1000 metric ton of CO2 equivalent) in 2000 and Emissions (1000 metric ton of CO2 equivalent) in 2008 in Serbia?
Offer a very short reply. 1424.6. What is the difference between the Emissions (1000 metric ton of CO2 equivalent) of 2005 and Emissions (1000 metric ton of CO2 equivalent) of 2008 in Serbia?
Your answer should be very brief. 848.9. What is the ratio of the Emissions (1000 metric ton of CO2 equivalent) in 1990 in Qatar to that in Romania?
Give a very brief answer. 0. What is the ratio of the Emissions (1000 metric ton of CO2 equivalent) in 2000 in Qatar to that in Romania?
Ensure brevity in your answer.  0.01. What is the ratio of the Emissions (1000 metric ton of CO2 equivalent) of 2005 in Qatar to that in Romania?
Provide a succinct answer. 0.01. What is the ratio of the Emissions (1000 metric ton of CO2 equivalent) of 2008 in Qatar to that in Romania?
Give a very brief answer. 0.01. What is the ratio of the Emissions (1000 metric ton of CO2 equivalent) in 2000 in Qatar to that in Russian Federation?
Keep it short and to the point. 0. What is the ratio of the Emissions (1000 metric ton of CO2 equivalent) in 2005 in Qatar to that in Russian Federation?
Ensure brevity in your answer.  0. What is the ratio of the Emissions (1000 metric ton of CO2 equivalent) of 2008 in Qatar to that in Russian Federation?
Offer a very short reply. 0. What is the ratio of the Emissions (1000 metric ton of CO2 equivalent) in 1990 in Qatar to that in Saudi Arabia?
Ensure brevity in your answer.  0.03. What is the ratio of the Emissions (1000 metric ton of CO2 equivalent) in 2000 in Qatar to that in Saudi Arabia?
Make the answer very short. 0.06. What is the ratio of the Emissions (1000 metric ton of CO2 equivalent) of 2005 in Qatar to that in Saudi Arabia?
Give a very brief answer. 0.03. What is the ratio of the Emissions (1000 metric ton of CO2 equivalent) of 2008 in Qatar to that in Saudi Arabia?
Your response must be concise. 0.06. What is the ratio of the Emissions (1000 metric ton of CO2 equivalent) of 1990 in Qatar to that in Senegal?
Your response must be concise. 0.02. What is the ratio of the Emissions (1000 metric ton of CO2 equivalent) in 2000 in Qatar to that in Senegal?
Ensure brevity in your answer.  0.02. What is the ratio of the Emissions (1000 metric ton of CO2 equivalent) in 2005 in Qatar to that in Senegal?
Make the answer very short. 0.01. What is the ratio of the Emissions (1000 metric ton of CO2 equivalent) in 2008 in Qatar to that in Senegal?
Your response must be concise. 0.02. What is the ratio of the Emissions (1000 metric ton of CO2 equivalent) of 1990 in Qatar to that in Serbia?
Offer a very short reply. 0.01. What is the ratio of the Emissions (1000 metric ton of CO2 equivalent) of 2000 in Qatar to that in Serbia?
Ensure brevity in your answer.  0.03. What is the ratio of the Emissions (1000 metric ton of CO2 equivalent) in 2005 in Qatar to that in Serbia?
Give a very brief answer. 0.02. What is the ratio of the Emissions (1000 metric ton of CO2 equivalent) in 2008 in Qatar to that in Serbia?
Give a very brief answer. 0.04. What is the ratio of the Emissions (1000 metric ton of CO2 equivalent) in 1990 in Romania to that in Russian Federation?
Provide a short and direct response. 0.12. What is the ratio of the Emissions (1000 metric ton of CO2 equivalent) of 2000 in Romania to that in Russian Federation?
Your answer should be compact. 0.14. What is the ratio of the Emissions (1000 metric ton of CO2 equivalent) of 2005 in Romania to that in Russian Federation?
Offer a terse response. 0.17. What is the ratio of the Emissions (1000 metric ton of CO2 equivalent) in 2008 in Romania to that in Russian Federation?
Provide a short and direct response. 0.21. What is the ratio of the Emissions (1000 metric ton of CO2 equivalent) of 1990 in Romania to that in Saudi Arabia?
Provide a short and direct response. 8.51. What is the ratio of the Emissions (1000 metric ton of CO2 equivalent) in 2000 in Romania to that in Saudi Arabia?
Offer a terse response. 4.36. What is the ratio of the Emissions (1000 metric ton of CO2 equivalent) of 2005 in Romania to that in Saudi Arabia?
Your response must be concise. 4.53. What is the ratio of the Emissions (1000 metric ton of CO2 equivalent) in 2008 in Romania to that in Saudi Arabia?
Give a very brief answer. 4.44. What is the ratio of the Emissions (1000 metric ton of CO2 equivalent) in 1990 in Romania to that in Senegal?
Your answer should be very brief. 4.24. What is the ratio of the Emissions (1000 metric ton of CO2 equivalent) in 2000 in Romania to that in Senegal?
Provide a succinct answer. 1.81. What is the ratio of the Emissions (1000 metric ton of CO2 equivalent) of 2005 in Romania to that in Senegal?
Make the answer very short. 1.77. What is the ratio of the Emissions (1000 metric ton of CO2 equivalent) of 2008 in Romania to that in Senegal?
Your answer should be very brief. 1.48. What is the ratio of the Emissions (1000 metric ton of CO2 equivalent) of 1990 in Romania to that in Serbia?
Provide a short and direct response. 2.52. What is the ratio of the Emissions (1000 metric ton of CO2 equivalent) in 2000 in Romania to that in Serbia?
Ensure brevity in your answer.  2.12. What is the ratio of the Emissions (1000 metric ton of CO2 equivalent) in 2005 in Romania to that in Serbia?
Give a very brief answer. 2.58. What is the ratio of the Emissions (1000 metric ton of CO2 equivalent) of 2008 in Romania to that in Serbia?
Keep it short and to the point. 3.46. What is the ratio of the Emissions (1000 metric ton of CO2 equivalent) of 1990 in Russian Federation to that in Saudi Arabia?
Make the answer very short. 72.03. What is the ratio of the Emissions (1000 metric ton of CO2 equivalent) in 2000 in Russian Federation to that in Saudi Arabia?
Make the answer very short. 30.11. What is the ratio of the Emissions (1000 metric ton of CO2 equivalent) in 2005 in Russian Federation to that in Saudi Arabia?
Provide a succinct answer. 26.39. What is the ratio of the Emissions (1000 metric ton of CO2 equivalent) of 2008 in Russian Federation to that in Saudi Arabia?
Provide a succinct answer. 20.94. What is the ratio of the Emissions (1000 metric ton of CO2 equivalent) of 1990 in Russian Federation to that in Senegal?
Provide a succinct answer. 35.86. What is the ratio of the Emissions (1000 metric ton of CO2 equivalent) in 2000 in Russian Federation to that in Senegal?
Your response must be concise. 12.49. What is the ratio of the Emissions (1000 metric ton of CO2 equivalent) of 2005 in Russian Federation to that in Senegal?
Provide a short and direct response. 10.3. What is the ratio of the Emissions (1000 metric ton of CO2 equivalent) of 2008 in Russian Federation to that in Senegal?
Offer a terse response. 6.97. What is the ratio of the Emissions (1000 metric ton of CO2 equivalent) in 1990 in Russian Federation to that in Serbia?
Ensure brevity in your answer.  21.35. What is the ratio of the Emissions (1000 metric ton of CO2 equivalent) in 2000 in Russian Federation to that in Serbia?
Provide a succinct answer. 14.61. What is the ratio of the Emissions (1000 metric ton of CO2 equivalent) of 2005 in Russian Federation to that in Serbia?
Make the answer very short. 15.01. What is the ratio of the Emissions (1000 metric ton of CO2 equivalent) in 2008 in Russian Federation to that in Serbia?
Provide a succinct answer. 16.35. What is the ratio of the Emissions (1000 metric ton of CO2 equivalent) in 1990 in Saudi Arabia to that in Senegal?
Your answer should be very brief. 0.5. What is the ratio of the Emissions (1000 metric ton of CO2 equivalent) in 2000 in Saudi Arabia to that in Senegal?
Offer a terse response. 0.41. What is the ratio of the Emissions (1000 metric ton of CO2 equivalent) in 2005 in Saudi Arabia to that in Senegal?
Offer a very short reply. 0.39. What is the ratio of the Emissions (1000 metric ton of CO2 equivalent) of 2008 in Saudi Arabia to that in Senegal?
Ensure brevity in your answer.  0.33. What is the ratio of the Emissions (1000 metric ton of CO2 equivalent) of 1990 in Saudi Arabia to that in Serbia?
Your answer should be very brief. 0.3. What is the ratio of the Emissions (1000 metric ton of CO2 equivalent) in 2000 in Saudi Arabia to that in Serbia?
Your response must be concise. 0.49. What is the ratio of the Emissions (1000 metric ton of CO2 equivalent) in 2005 in Saudi Arabia to that in Serbia?
Your answer should be very brief. 0.57. What is the ratio of the Emissions (1000 metric ton of CO2 equivalent) in 2008 in Saudi Arabia to that in Serbia?
Keep it short and to the point. 0.78. What is the ratio of the Emissions (1000 metric ton of CO2 equivalent) in 1990 in Senegal to that in Serbia?
Your answer should be very brief. 0.6. What is the ratio of the Emissions (1000 metric ton of CO2 equivalent) of 2000 in Senegal to that in Serbia?
Your answer should be very brief. 1.17. What is the ratio of the Emissions (1000 metric ton of CO2 equivalent) in 2005 in Senegal to that in Serbia?
Your answer should be compact. 1.46. What is the ratio of the Emissions (1000 metric ton of CO2 equivalent) in 2008 in Senegal to that in Serbia?
Offer a terse response. 2.35. What is the difference between the highest and the second highest Emissions (1000 metric ton of CO2 equivalent) of 1990?
Offer a very short reply. 1.17e+05. What is the difference between the highest and the second highest Emissions (1000 metric ton of CO2 equivalent) of 2000?
Your answer should be compact. 4.97e+04. What is the difference between the highest and the second highest Emissions (1000 metric ton of CO2 equivalent) in 2005?
Your answer should be very brief. 4.23e+04. What is the difference between the highest and the second highest Emissions (1000 metric ton of CO2 equivalent) of 2008?
Provide a short and direct response. 3.29e+04. What is the difference between the highest and the lowest Emissions (1000 metric ton of CO2 equivalent) of 1990?
Offer a very short reply. 1.32e+05. What is the difference between the highest and the lowest Emissions (1000 metric ton of CO2 equivalent) in 2000?
Ensure brevity in your answer.  5.80e+04. What is the difference between the highest and the lowest Emissions (1000 metric ton of CO2 equivalent) of 2005?
Your answer should be very brief. 5.10e+04. What is the difference between the highest and the lowest Emissions (1000 metric ton of CO2 equivalent) of 2008?
Ensure brevity in your answer.  4.16e+04. 